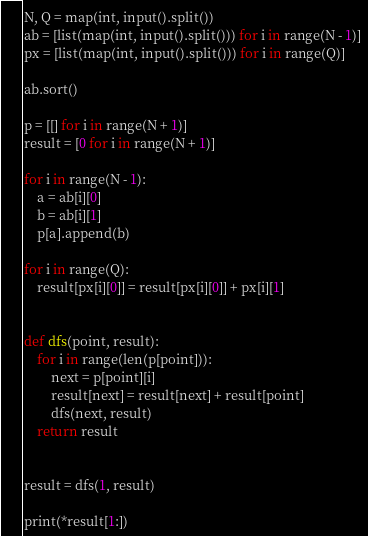Convert code to text. <code><loc_0><loc_0><loc_500><loc_500><_Python_>N, Q = map(int, input().split())
ab = [list(map(int, input().split())) for i in range(N - 1)]
px = [list(map(int, input().split())) for i in range(Q)]

ab.sort()

p = [[] for i in range(N + 1)]
result = [0 for i in range(N + 1)]

for i in range(N - 1):
    a = ab[i][0]
    b = ab[i][1]
    p[a].append(b)

for i in range(Q):
    result[px[i][0]] = result[px[i][0]] + px[i][1]


def dfs(point, result):
    for i in range(len(p[point])):
        next = p[point][i]
        result[next] = result[next] + result[point]
        dfs(next, result)
    return result


result = dfs(1, result)

print(*result[1:])</code> 